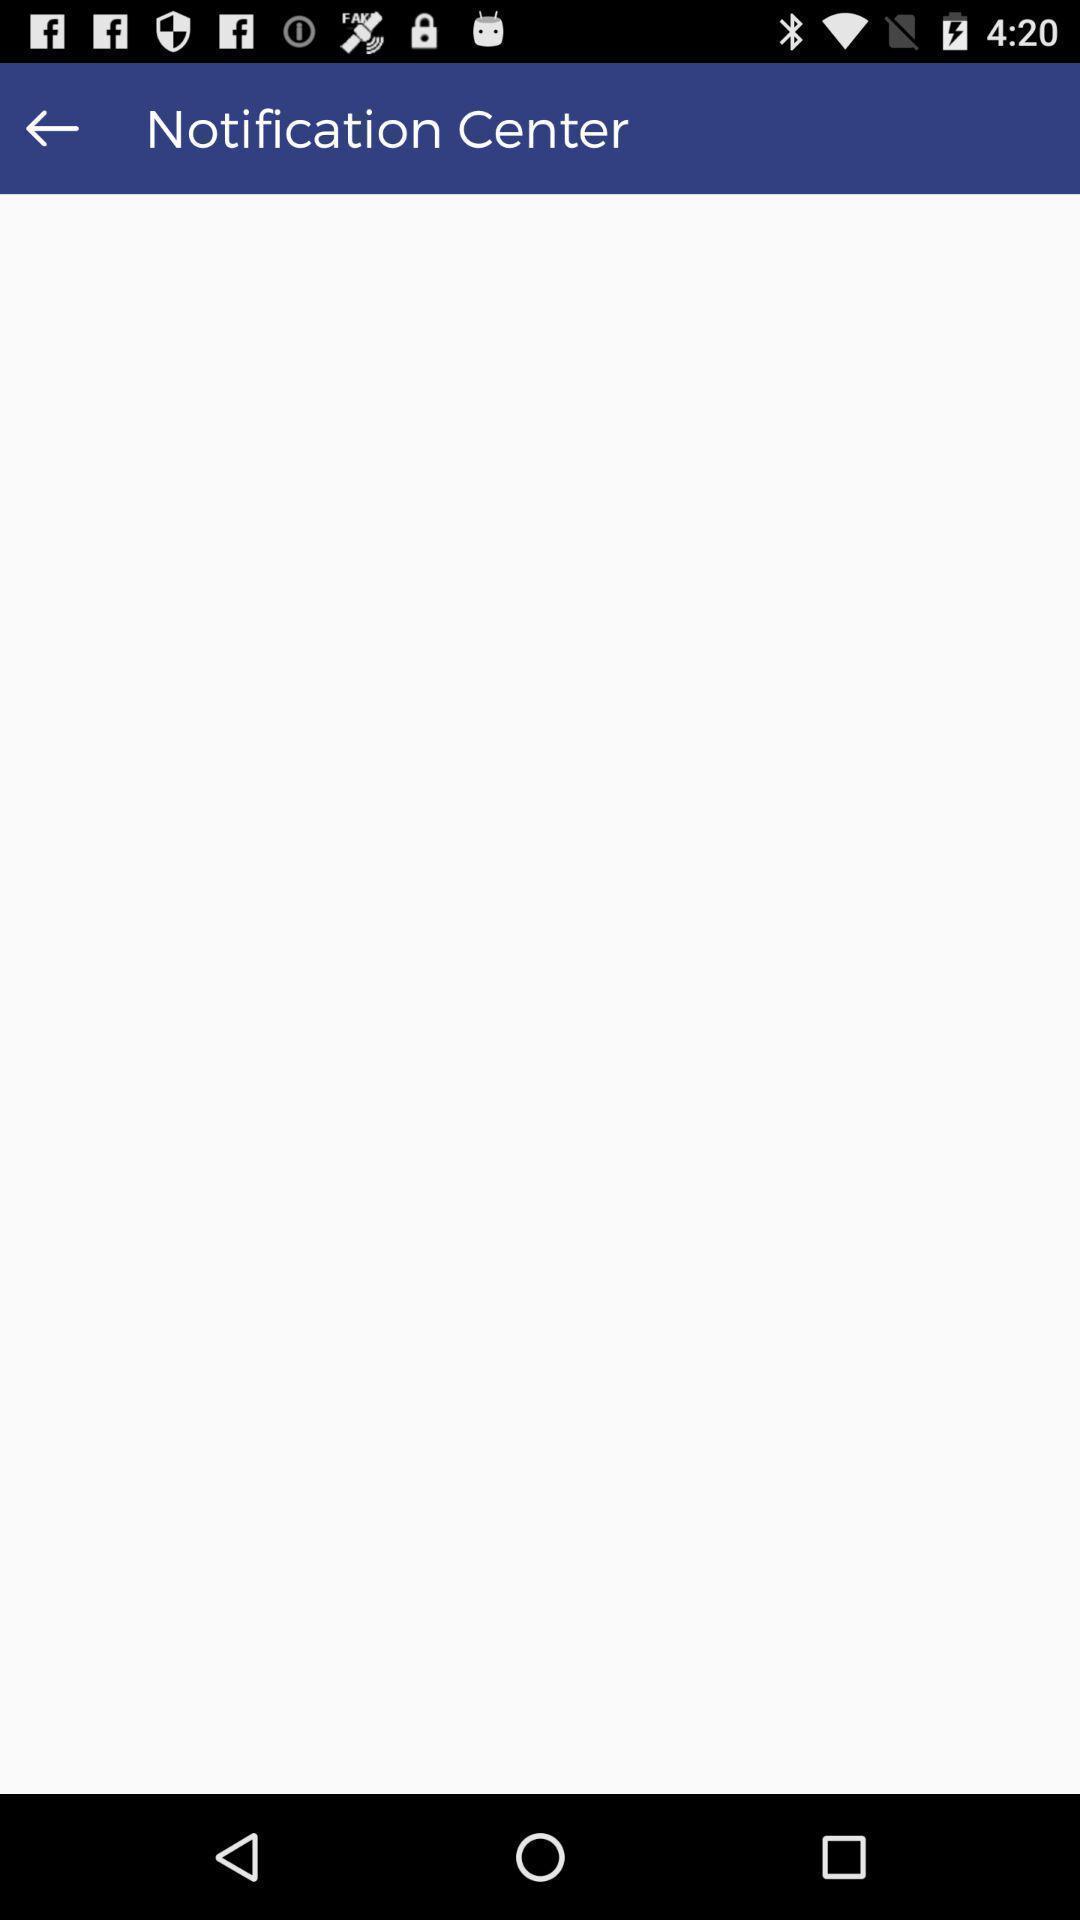Explain what's happening in this screen capture. Screen page of a notifications in a news app. 